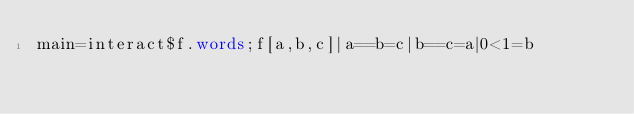Convert code to text. <code><loc_0><loc_0><loc_500><loc_500><_Haskell_>main=interact$f.words;f[a,b,c]|a==b=c|b==c=a|0<1=b</code> 